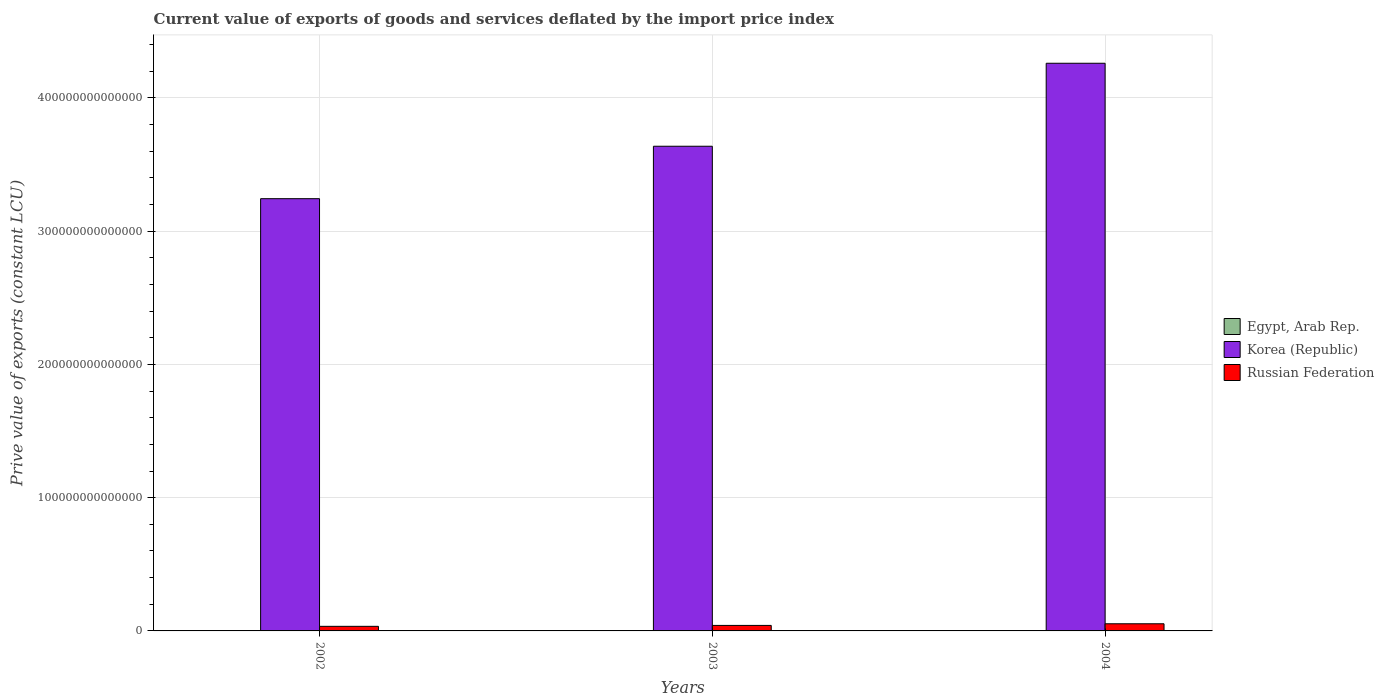How many groups of bars are there?
Provide a succinct answer. 3. Are the number of bars per tick equal to the number of legend labels?
Offer a terse response. Yes. How many bars are there on the 2nd tick from the left?
Keep it short and to the point. 3. What is the label of the 2nd group of bars from the left?
Provide a short and direct response. 2003. What is the prive value of exports in Egypt, Arab Rep. in 2002?
Ensure brevity in your answer.  6.94e+1. Across all years, what is the maximum prive value of exports in Russian Federation?
Your answer should be very brief. 5.36e+12. Across all years, what is the minimum prive value of exports in Egypt, Arab Rep.?
Offer a very short reply. 6.94e+1. In which year was the prive value of exports in Egypt, Arab Rep. minimum?
Ensure brevity in your answer.  2002. What is the total prive value of exports in Russian Federation in the graph?
Keep it short and to the point. 1.29e+13. What is the difference between the prive value of exports in Russian Federation in 2003 and that in 2004?
Your answer should be very brief. -1.23e+12. What is the difference between the prive value of exports in Egypt, Arab Rep. in 2003 and the prive value of exports in Korea (Republic) in 2002?
Your answer should be compact. -3.24e+14. What is the average prive value of exports in Russian Federation per year?
Your response must be concise. 4.31e+12. In the year 2003, what is the difference between the prive value of exports in Egypt, Arab Rep. and prive value of exports in Russian Federation?
Your response must be concise. -4.06e+12. What is the ratio of the prive value of exports in Egypt, Arab Rep. in 2002 to that in 2004?
Your answer should be compact. 0.71. Is the prive value of exports in Russian Federation in 2002 less than that in 2003?
Your answer should be compact. Yes. Is the difference between the prive value of exports in Egypt, Arab Rep. in 2002 and 2004 greater than the difference between the prive value of exports in Russian Federation in 2002 and 2004?
Keep it short and to the point. Yes. What is the difference between the highest and the second highest prive value of exports in Egypt, Arab Rep.?
Provide a succinct answer. 1.95e+1. What is the difference between the highest and the lowest prive value of exports in Korea (Republic)?
Offer a very short reply. 1.02e+14. In how many years, is the prive value of exports in Korea (Republic) greater than the average prive value of exports in Korea (Republic) taken over all years?
Your answer should be compact. 1. What does the 1st bar from the left in 2004 represents?
Your answer should be very brief. Egypt, Arab Rep. What does the 1st bar from the right in 2004 represents?
Ensure brevity in your answer.  Russian Federation. Is it the case that in every year, the sum of the prive value of exports in Russian Federation and prive value of exports in Egypt, Arab Rep. is greater than the prive value of exports in Korea (Republic)?
Offer a terse response. No. How many bars are there?
Give a very brief answer. 9. Are all the bars in the graph horizontal?
Offer a terse response. No. What is the difference between two consecutive major ticks on the Y-axis?
Make the answer very short. 1.00e+14. Does the graph contain grids?
Ensure brevity in your answer.  Yes. How many legend labels are there?
Ensure brevity in your answer.  3. How are the legend labels stacked?
Offer a terse response. Vertical. What is the title of the graph?
Keep it short and to the point. Current value of exports of goods and services deflated by the import price index. Does "Oman" appear as one of the legend labels in the graph?
Give a very brief answer. No. What is the label or title of the X-axis?
Provide a short and direct response. Years. What is the label or title of the Y-axis?
Your answer should be very brief. Prive value of exports (constant LCU). What is the Prive value of exports (constant LCU) in Egypt, Arab Rep. in 2002?
Make the answer very short. 6.94e+1. What is the Prive value of exports (constant LCU) in Korea (Republic) in 2002?
Offer a very short reply. 3.24e+14. What is the Prive value of exports (constant LCU) of Russian Federation in 2002?
Keep it short and to the point. 3.44e+12. What is the Prive value of exports (constant LCU) in Egypt, Arab Rep. in 2003?
Ensure brevity in your answer.  7.78e+1. What is the Prive value of exports (constant LCU) of Korea (Republic) in 2003?
Your answer should be compact. 3.64e+14. What is the Prive value of exports (constant LCU) of Russian Federation in 2003?
Keep it short and to the point. 4.14e+12. What is the Prive value of exports (constant LCU) in Egypt, Arab Rep. in 2004?
Provide a succinct answer. 9.73e+1. What is the Prive value of exports (constant LCU) in Korea (Republic) in 2004?
Your answer should be very brief. 4.26e+14. What is the Prive value of exports (constant LCU) of Russian Federation in 2004?
Make the answer very short. 5.36e+12. Across all years, what is the maximum Prive value of exports (constant LCU) in Egypt, Arab Rep.?
Offer a very short reply. 9.73e+1. Across all years, what is the maximum Prive value of exports (constant LCU) of Korea (Republic)?
Offer a very short reply. 4.26e+14. Across all years, what is the maximum Prive value of exports (constant LCU) of Russian Federation?
Keep it short and to the point. 5.36e+12. Across all years, what is the minimum Prive value of exports (constant LCU) in Egypt, Arab Rep.?
Keep it short and to the point. 6.94e+1. Across all years, what is the minimum Prive value of exports (constant LCU) in Korea (Republic)?
Provide a short and direct response. 3.24e+14. Across all years, what is the minimum Prive value of exports (constant LCU) of Russian Federation?
Give a very brief answer. 3.44e+12. What is the total Prive value of exports (constant LCU) of Egypt, Arab Rep. in the graph?
Provide a short and direct response. 2.44e+11. What is the total Prive value of exports (constant LCU) of Korea (Republic) in the graph?
Your response must be concise. 1.11e+15. What is the total Prive value of exports (constant LCU) of Russian Federation in the graph?
Offer a terse response. 1.29e+13. What is the difference between the Prive value of exports (constant LCU) of Egypt, Arab Rep. in 2002 and that in 2003?
Provide a short and direct response. -8.37e+09. What is the difference between the Prive value of exports (constant LCU) of Korea (Republic) in 2002 and that in 2003?
Your response must be concise. -3.94e+13. What is the difference between the Prive value of exports (constant LCU) of Russian Federation in 2002 and that in 2003?
Provide a succinct answer. -6.94e+11. What is the difference between the Prive value of exports (constant LCU) in Egypt, Arab Rep. in 2002 and that in 2004?
Make the answer very short. -2.79e+1. What is the difference between the Prive value of exports (constant LCU) in Korea (Republic) in 2002 and that in 2004?
Provide a short and direct response. -1.02e+14. What is the difference between the Prive value of exports (constant LCU) in Russian Federation in 2002 and that in 2004?
Offer a very short reply. -1.92e+12. What is the difference between the Prive value of exports (constant LCU) in Egypt, Arab Rep. in 2003 and that in 2004?
Ensure brevity in your answer.  -1.95e+1. What is the difference between the Prive value of exports (constant LCU) of Korea (Republic) in 2003 and that in 2004?
Your answer should be compact. -6.23e+13. What is the difference between the Prive value of exports (constant LCU) of Russian Federation in 2003 and that in 2004?
Offer a very short reply. -1.23e+12. What is the difference between the Prive value of exports (constant LCU) of Egypt, Arab Rep. in 2002 and the Prive value of exports (constant LCU) of Korea (Republic) in 2003?
Provide a short and direct response. -3.64e+14. What is the difference between the Prive value of exports (constant LCU) of Egypt, Arab Rep. in 2002 and the Prive value of exports (constant LCU) of Russian Federation in 2003?
Give a very brief answer. -4.07e+12. What is the difference between the Prive value of exports (constant LCU) in Korea (Republic) in 2002 and the Prive value of exports (constant LCU) in Russian Federation in 2003?
Provide a succinct answer. 3.20e+14. What is the difference between the Prive value of exports (constant LCU) in Egypt, Arab Rep. in 2002 and the Prive value of exports (constant LCU) in Korea (Republic) in 2004?
Keep it short and to the point. -4.26e+14. What is the difference between the Prive value of exports (constant LCU) of Egypt, Arab Rep. in 2002 and the Prive value of exports (constant LCU) of Russian Federation in 2004?
Your answer should be very brief. -5.29e+12. What is the difference between the Prive value of exports (constant LCU) of Korea (Republic) in 2002 and the Prive value of exports (constant LCU) of Russian Federation in 2004?
Provide a succinct answer. 3.19e+14. What is the difference between the Prive value of exports (constant LCU) in Egypt, Arab Rep. in 2003 and the Prive value of exports (constant LCU) in Korea (Republic) in 2004?
Ensure brevity in your answer.  -4.26e+14. What is the difference between the Prive value of exports (constant LCU) in Egypt, Arab Rep. in 2003 and the Prive value of exports (constant LCU) in Russian Federation in 2004?
Ensure brevity in your answer.  -5.29e+12. What is the difference between the Prive value of exports (constant LCU) in Korea (Republic) in 2003 and the Prive value of exports (constant LCU) in Russian Federation in 2004?
Your response must be concise. 3.58e+14. What is the average Prive value of exports (constant LCU) in Egypt, Arab Rep. per year?
Keep it short and to the point. 8.15e+1. What is the average Prive value of exports (constant LCU) in Korea (Republic) per year?
Offer a very short reply. 3.71e+14. What is the average Prive value of exports (constant LCU) of Russian Federation per year?
Offer a very short reply. 4.31e+12. In the year 2002, what is the difference between the Prive value of exports (constant LCU) in Egypt, Arab Rep. and Prive value of exports (constant LCU) in Korea (Republic)?
Offer a terse response. -3.24e+14. In the year 2002, what is the difference between the Prive value of exports (constant LCU) in Egypt, Arab Rep. and Prive value of exports (constant LCU) in Russian Federation?
Make the answer very short. -3.37e+12. In the year 2002, what is the difference between the Prive value of exports (constant LCU) in Korea (Republic) and Prive value of exports (constant LCU) in Russian Federation?
Provide a succinct answer. 3.21e+14. In the year 2003, what is the difference between the Prive value of exports (constant LCU) in Egypt, Arab Rep. and Prive value of exports (constant LCU) in Korea (Republic)?
Your answer should be very brief. -3.64e+14. In the year 2003, what is the difference between the Prive value of exports (constant LCU) in Egypt, Arab Rep. and Prive value of exports (constant LCU) in Russian Federation?
Offer a very short reply. -4.06e+12. In the year 2003, what is the difference between the Prive value of exports (constant LCU) of Korea (Republic) and Prive value of exports (constant LCU) of Russian Federation?
Keep it short and to the point. 3.60e+14. In the year 2004, what is the difference between the Prive value of exports (constant LCU) in Egypt, Arab Rep. and Prive value of exports (constant LCU) in Korea (Republic)?
Ensure brevity in your answer.  -4.26e+14. In the year 2004, what is the difference between the Prive value of exports (constant LCU) of Egypt, Arab Rep. and Prive value of exports (constant LCU) of Russian Federation?
Keep it short and to the point. -5.27e+12. In the year 2004, what is the difference between the Prive value of exports (constant LCU) in Korea (Republic) and Prive value of exports (constant LCU) in Russian Federation?
Your response must be concise. 4.21e+14. What is the ratio of the Prive value of exports (constant LCU) of Egypt, Arab Rep. in 2002 to that in 2003?
Your answer should be very brief. 0.89. What is the ratio of the Prive value of exports (constant LCU) in Korea (Republic) in 2002 to that in 2003?
Offer a terse response. 0.89. What is the ratio of the Prive value of exports (constant LCU) in Russian Federation in 2002 to that in 2003?
Make the answer very short. 0.83. What is the ratio of the Prive value of exports (constant LCU) in Egypt, Arab Rep. in 2002 to that in 2004?
Your answer should be compact. 0.71. What is the ratio of the Prive value of exports (constant LCU) in Korea (Republic) in 2002 to that in 2004?
Provide a succinct answer. 0.76. What is the ratio of the Prive value of exports (constant LCU) in Russian Federation in 2002 to that in 2004?
Give a very brief answer. 0.64. What is the ratio of the Prive value of exports (constant LCU) in Egypt, Arab Rep. in 2003 to that in 2004?
Provide a succinct answer. 0.8. What is the ratio of the Prive value of exports (constant LCU) of Korea (Republic) in 2003 to that in 2004?
Offer a very short reply. 0.85. What is the ratio of the Prive value of exports (constant LCU) in Russian Federation in 2003 to that in 2004?
Give a very brief answer. 0.77. What is the difference between the highest and the second highest Prive value of exports (constant LCU) in Egypt, Arab Rep.?
Keep it short and to the point. 1.95e+1. What is the difference between the highest and the second highest Prive value of exports (constant LCU) of Korea (Republic)?
Offer a very short reply. 6.23e+13. What is the difference between the highest and the second highest Prive value of exports (constant LCU) of Russian Federation?
Make the answer very short. 1.23e+12. What is the difference between the highest and the lowest Prive value of exports (constant LCU) in Egypt, Arab Rep.?
Your answer should be compact. 2.79e+1. What is the difference between the highest and the lowest Prive value of exports (constant LCU) of Korea (Republic)?
Your response must be concise. 1.02e+14. What is the difference between the highest and the lowest Prive value of exports (constant LCU) of Russian Federation?
Your answer should be very brief. 1.92e+12. 